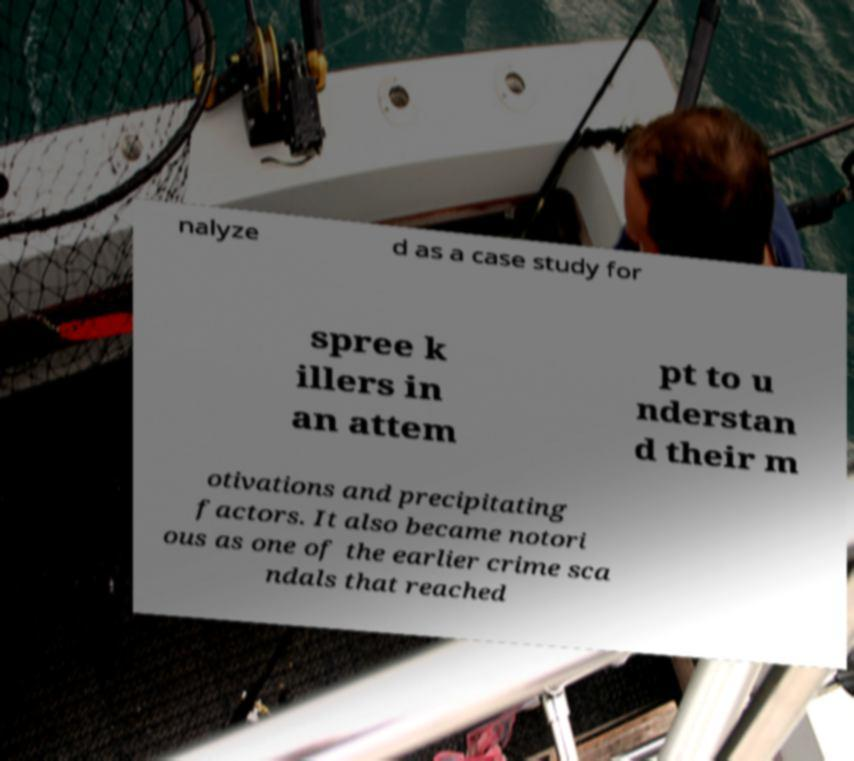Please identify and transcribe the text found in this image. nalyze d as a case study for spree k illers in an attem pt to u nderstan d their m otivations and precipitating factors. It also became notori ous as one of the earlier crime sca ndals that reached 